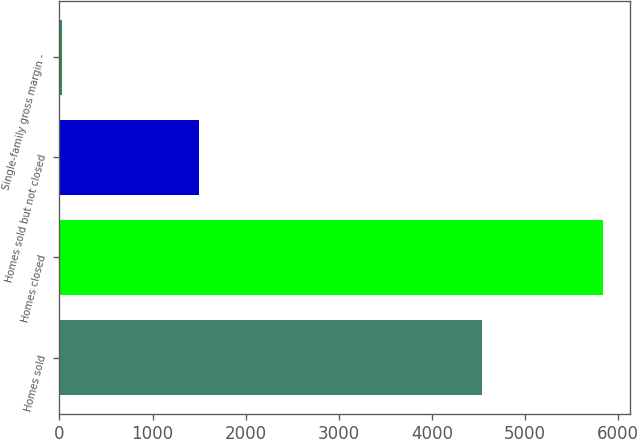Convert chart to OTSL. <chart><loc_0><loc_0><loc_500><loc_500><bar_chart><fcel>Homes sold<fcel>Homes closed<fcel>Homes sold but not closed<fcel>Single-family gross margin -<nl><fcel>4541<fcel>5836<fcel>1499<fcel>27.6<nl></chart> 